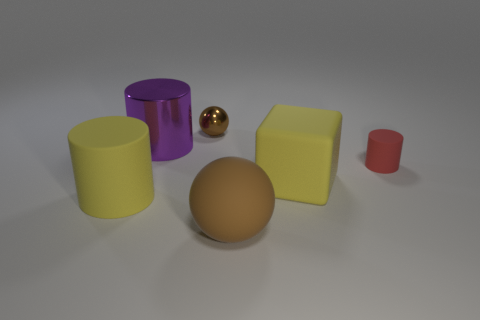Subtract all red rubber cylinders. How many cylinders are left? 2 Add 2 purple matte objects. How many objects exist? 8 Subtract all purple cylinders. How many cylinders are left? 2 Subtract 1 blocks. How many blocks are left? 0 Subtract all cubes. How many objects are left? 5 Subtract all red blocks. How many green spheres are left? 0 Subtract all big green metal things. Subtract all purple shiny objects. How many objects are left? 5 Add 4 rubber spheres. How many rubber spheres are left? 5 Add 6 purple metallic objects. How many purple metallic objects exist? 7 Subtract 0 blue cubes. How many objects are left? 6 